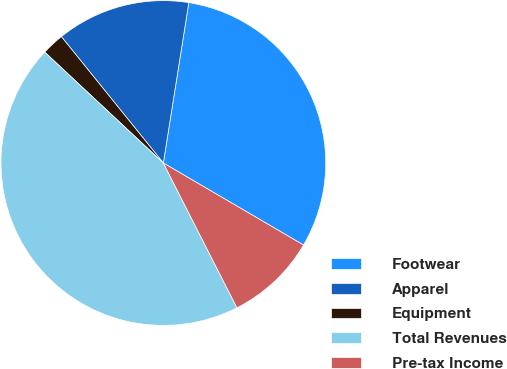Convert chart. <chart><loc_0><loc_0><loc_500><loc_500><pie_chart><fcel>Footwear<fcel>Apparel<fcel>Equipment<fcel>Total Revenues<fcel>Pre-tax Income<nl><fcel>30.92%<fcel>13.31%<fcel>2.23%<fcel>44.45%<fcel>9.09%<nl></chart> 